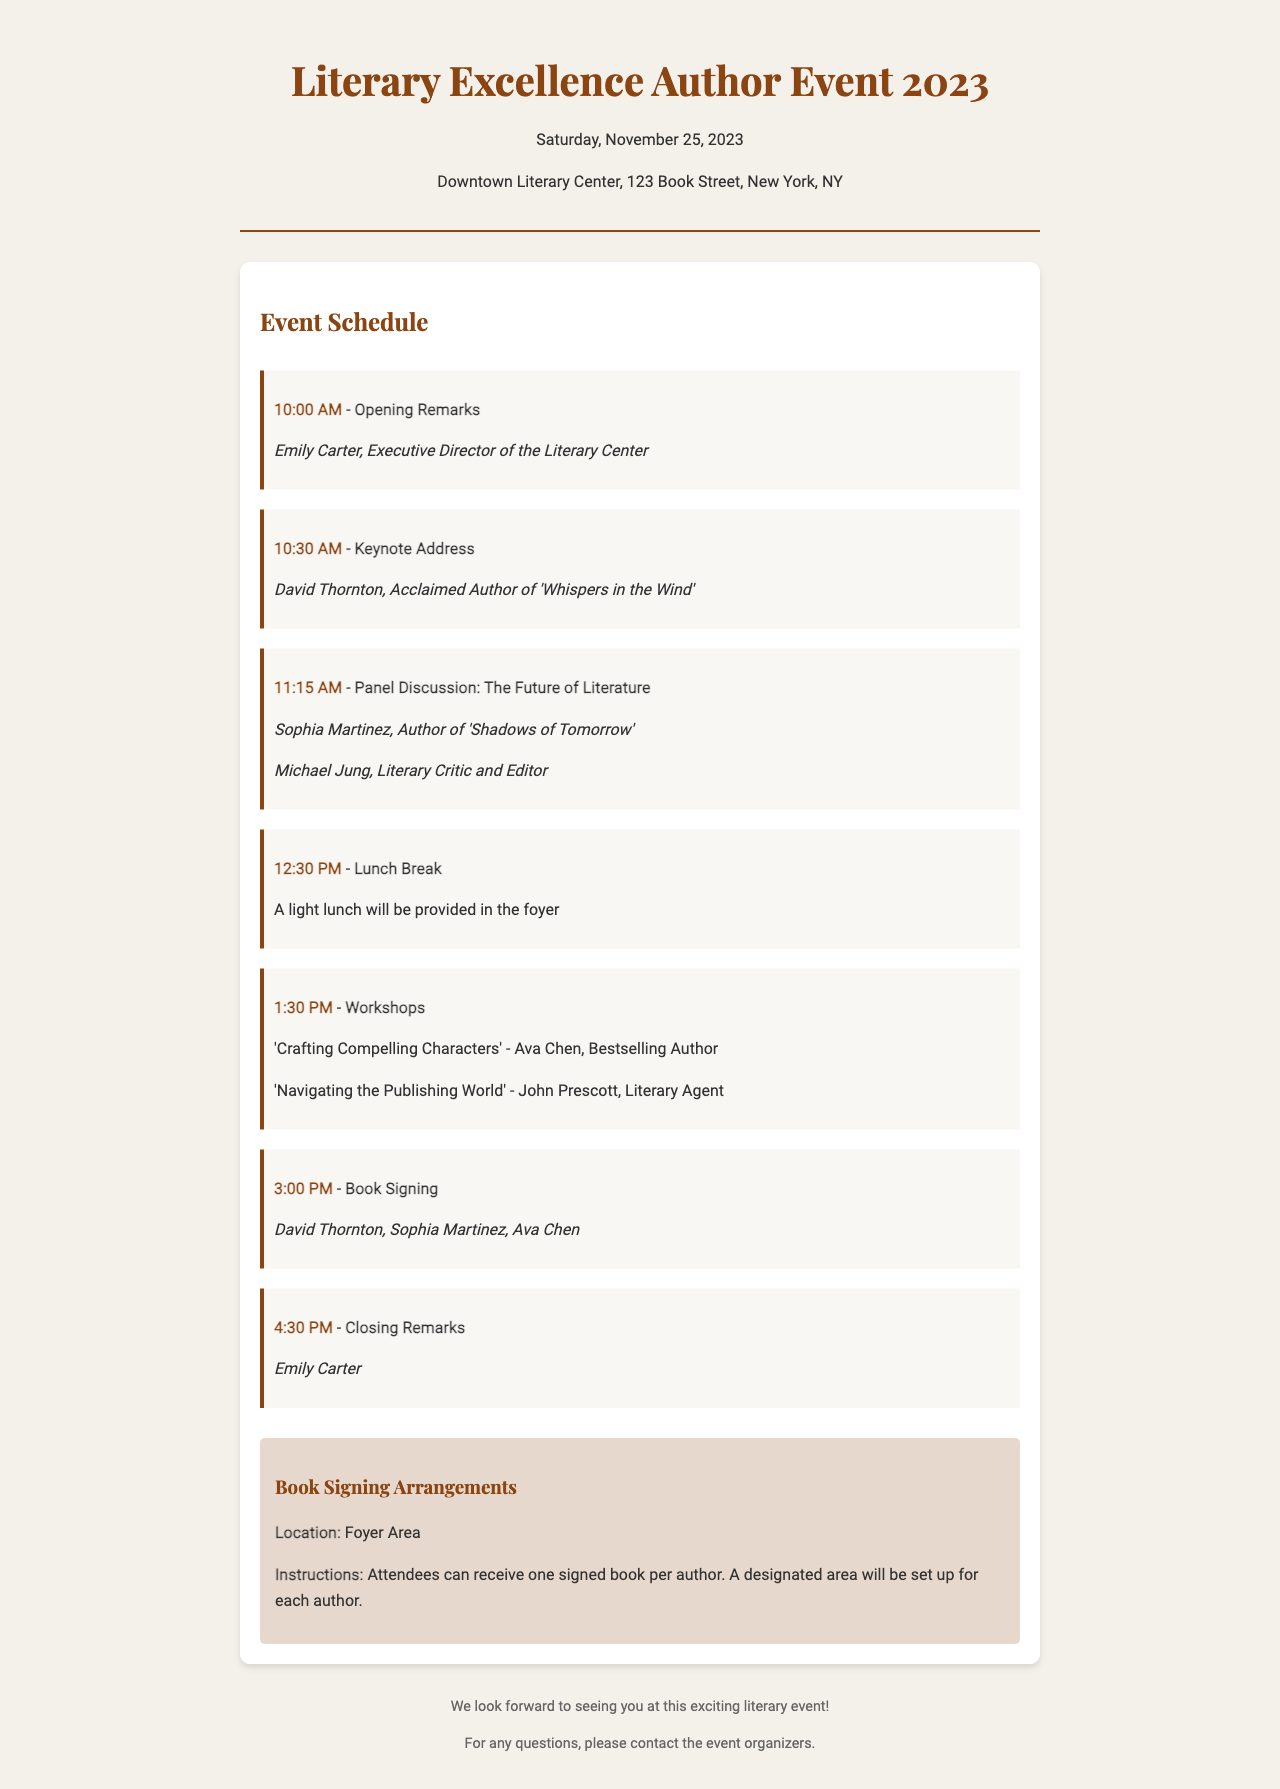What is the date of the event? The document states that the event will take place on Saturday, November 25, 2023.
Answer: November 25, 2023 Who is the keynote speaker? According to the schedule, the keynote address will be given by David Thornton.
Answer: David Thornton What time does the book signing start? The schedule indicates that the book signing begins at 3:00 PM.
Answer: 3:00 PM What is one of the workshop topics? The document lists 'Crafting Compelling Characters' as one of the workshop topics.
Answer: Crafting Compelling Characters Which author will give the closing remarks? The schedule specifies that Emily Carter will provide the closing remarks.
Answer: Emily Carter What is required for the book signing? The instructions indicate that attendees can receive one signed book per author.
Answer: One signed book per author Where will the book signing take place? The document states that the book signing location is the Foyer Area.
Answer: Foyer Area How long is the lunch break scheduled for? The schedule shows that the lunch break is from 12:30 PM to 1:30 PM, indicating it lasts for one hour.
Answer: One hour What literary role does Michael Jung have in the panel discussion? The document notes that Michael Jung is described as a Literary Critic and Editor in the panel discussion.
Answer: Literary Critic and Editor 